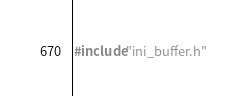<code> <loc_0><loc_0><loc_500><loc_500><_C++_>#include"ini_buffer.h"
</code> 